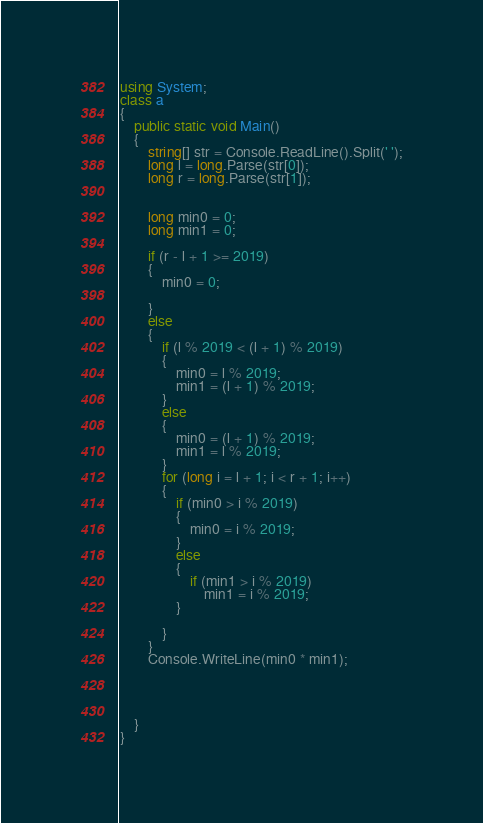<code> <loc_0><loc_0><loc_500><loc_500><_C#_>using System;
class a
{
    public static void Main()
    {
        string[] str = Console.ReadLine().Split(' ');
        long l = long.Parse(str[0]);
        long r = long.Parse(str[1]);

     
        long min0 = 0;
        long min1 = 0;

        if (r - l + 1 >= 2019)
        {
            min0 = 0;

        }
        else
        {
            if (l % 2019 < (l + 1) % 2019)
            {
                min0 = l % 2019;
                min1 = (l + 1) % 2019;
            }
            else
            {
                min0 = (l + 1) % 2019;
                min1 = l % 2019;
            }
            for (long i = l + 1; i < r + 1; i++)
            {
                if (min0 > i % 2019)
                {
                    min0 = i % 2019;
                }
                else
                {
                    if (min1 > i % 2019)
                        min1 = i % 2019;
                }

            }
        }
        Console.WriteLine(min0 * min1);




    }
}</code> 